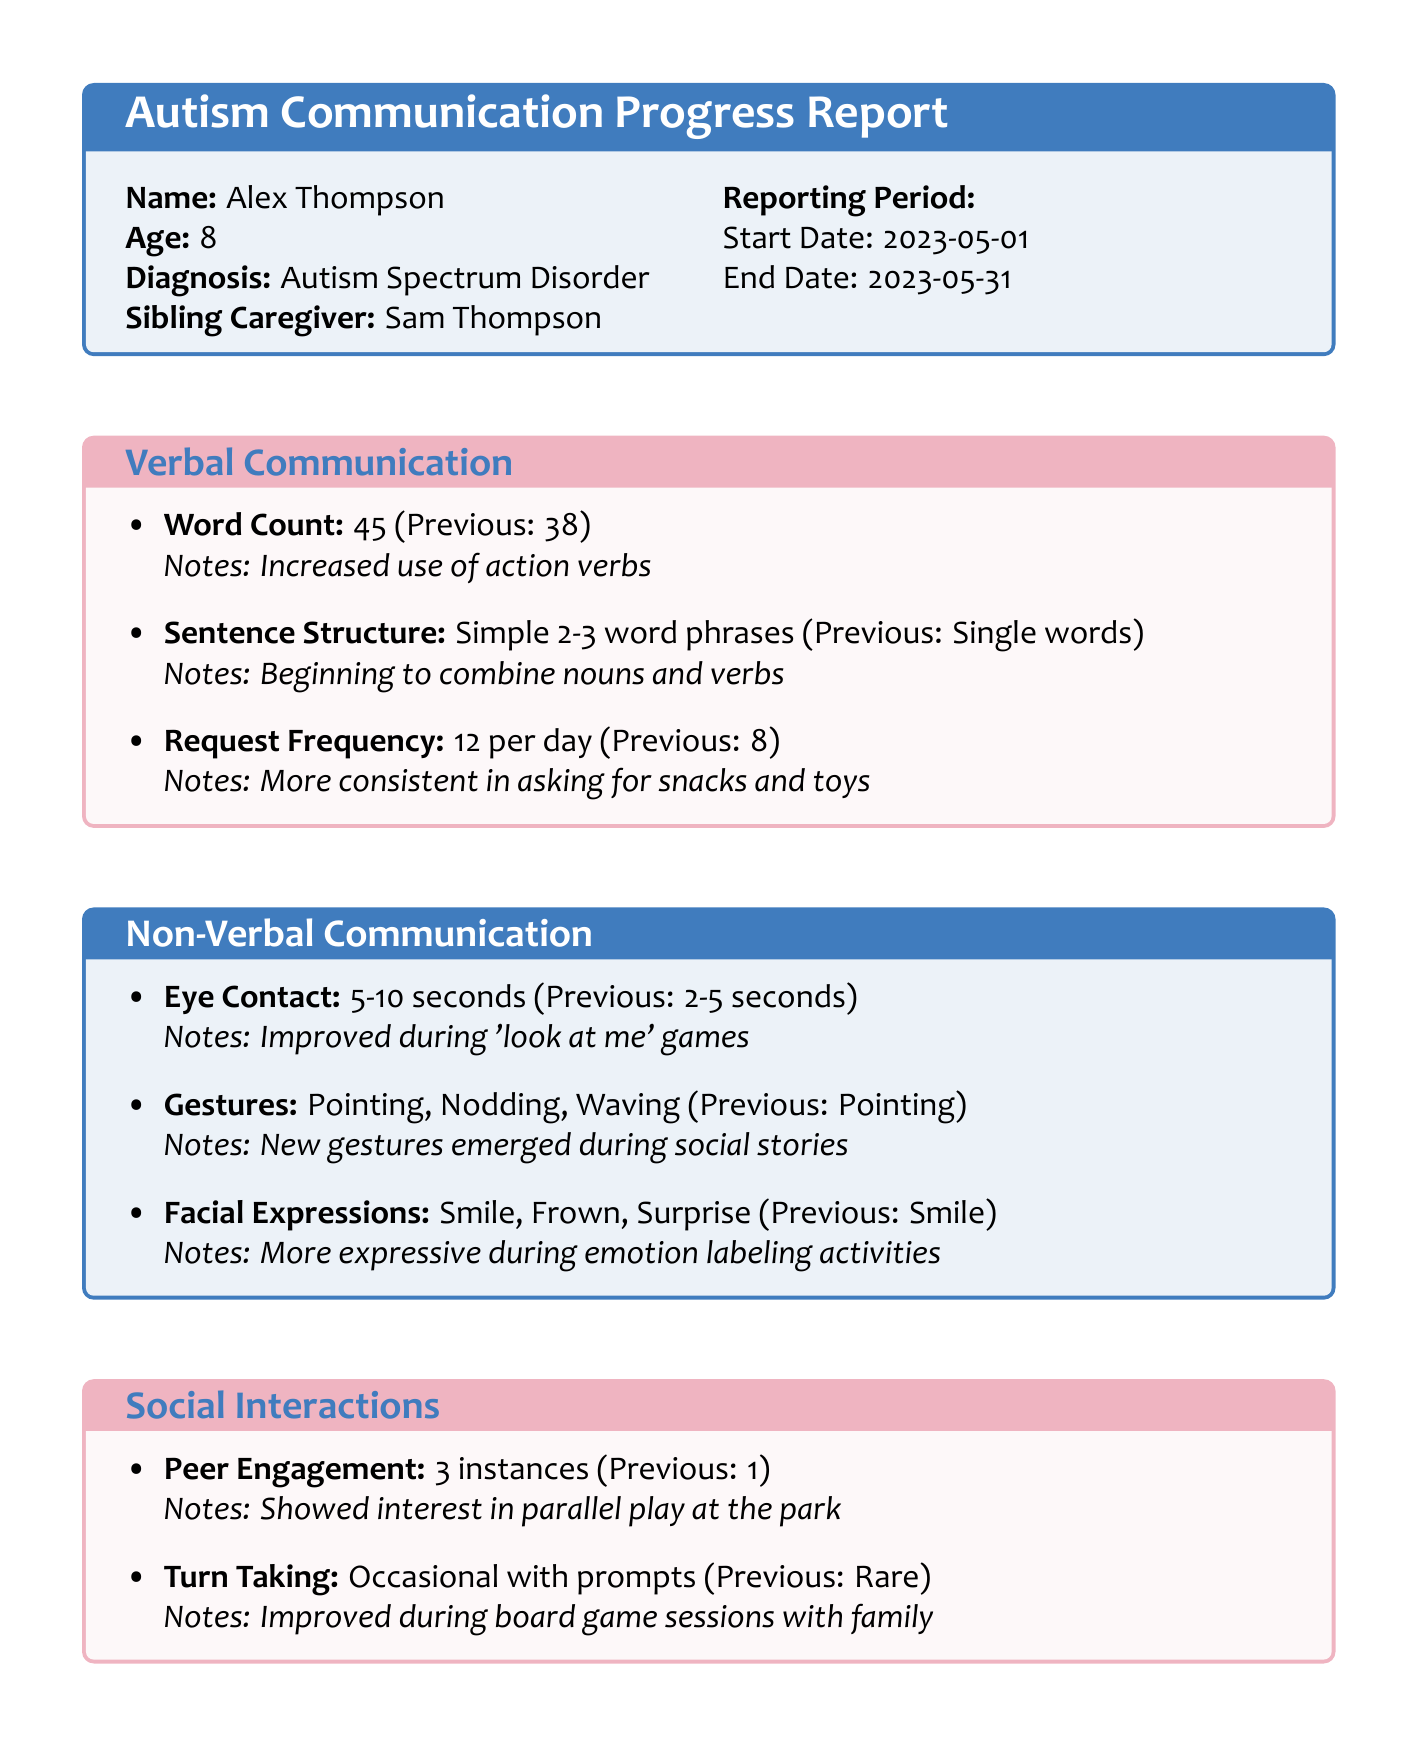What is the name of the patient? The name of the patient is found in the patient info section of the document.
Answer: Alex Thompson What is the age of Alex Thompson? The age is clearly stated in the patient info section.
Answer: 8 How many distinct words did Alex use this reporting period? This information is provided in the verbal communication section under word count.
Answer: 45 What is the frequency of verbal requests made by Alex each day? This is specified in the verbal communication section in request frequency.
Answer: 12 What improvements were noted in eye contact duration? Eye contact duration details are provided in the non-verbal communication section.
Answer: 5-10 seconds How many instances of initiating play with peers were recorded? This count is mentioned in the social interactions section under peer engagement.
Answer: 3 What are the goals for the next period? The document contains a list of goals for the future in the goals section.
Answer: Introduce 10 new vocabulary words Who is the speech language pathologist? The name of the therapist is included in the therapist notes section.
Answer: Dr. Emily Chen What observations did Sam Thompson have regarding Alex's communication? Insights from the sibling caregiver can be found in the sibling caregiver observations section.
Answer: More willing to communicate during play sessions 